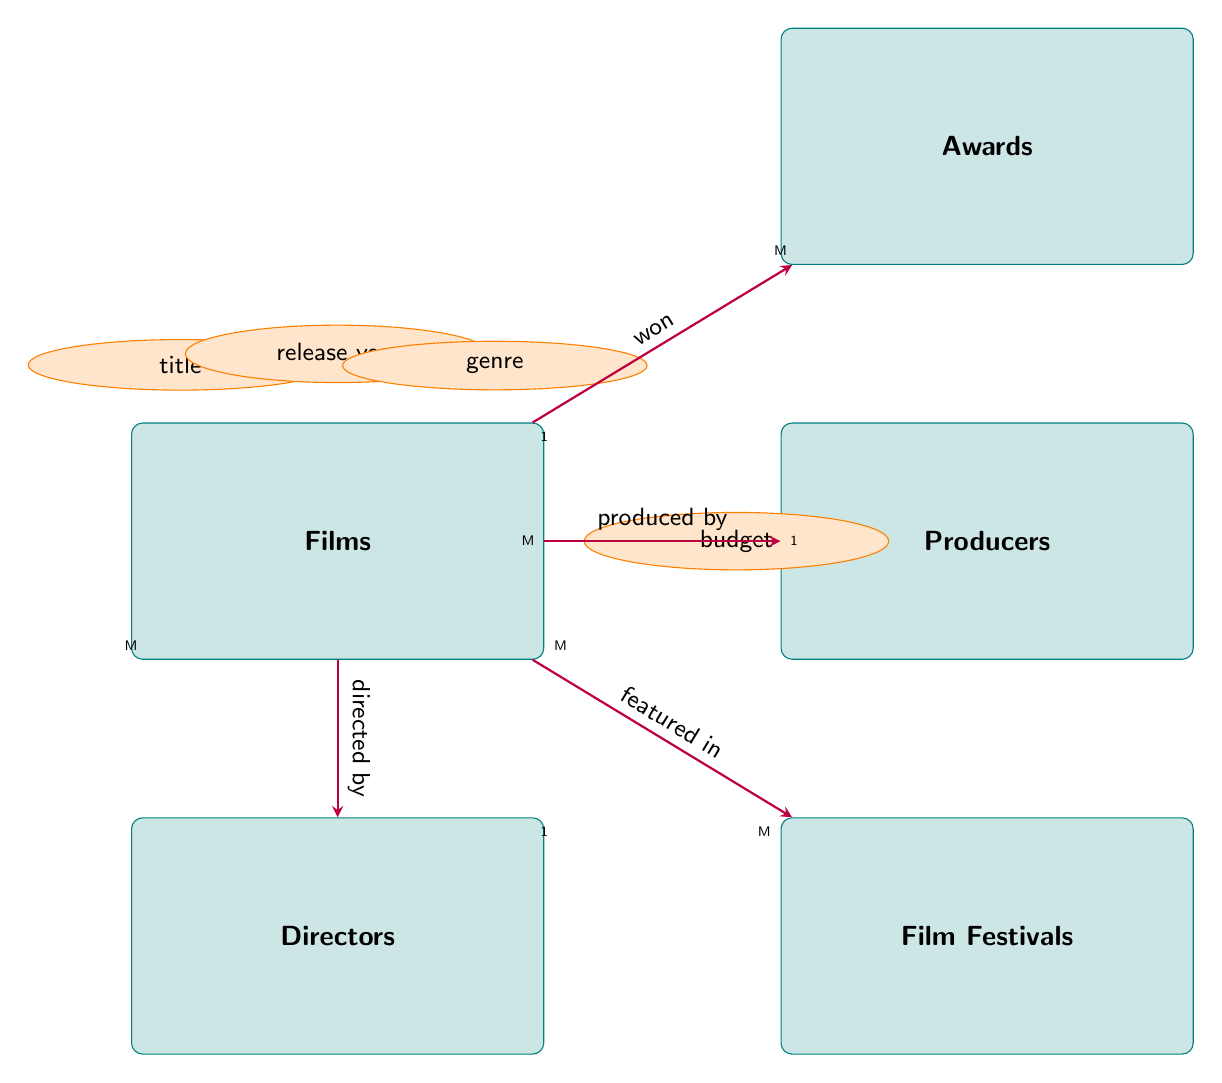What are the attributes of the Films entity? The Films entity includes the attributes title, release year, genre, and budget, as indicated in the diagram.
Answer: title, release year, genre, budget How many attributes does the Producers entity have? Upon examining the diagram, the Producers entity shows three attributes: name, company, and experience years. Thus, the total number is three.
Answer: 3 Which entity is directed by Directors? According to the relationship specified in the diagram, the entity Films is directed by Directors, indicating a direct connection in their relationship.
Answer: Films What is the cardinality of the relationship between Films and Directors? The diagram shows a Many-to-One cardinality for the relationship between Films and Directors, meaning multiple films can be directed by one director.
Answer: Many-to-One How many awards can a film win? The relationship labeled "won" indicates that a film can belong to one or many Awards, meaning a single film can win multiple awards, suggesting an One-to-Many relationship.
Answer: One-to-Many Which entity has a Many-to-Many relationship with Films? The diagram highlights that Films and Film Festivals share a Many-to-Many relationship, allowing films to be featured in numerous festivals.
Answer: Film Festivals How many directors can direct multiple films? The diagram indicates that Directors can direct multiple Films (One-to-Many). Hence, one director can be linked to several films.
Answer: One Which entity produces Films? The diagram specifies that the Producers entity has a direct relationship with Films under "produced by," indicating that producers have the role of creating films.
Answer: Producers What is the relationship type between Films and Festivals? The relationship between Films and Film Festivals is described in the diagram as "featured in," indicating that films can appear in various festivals.
Answer: featured in 